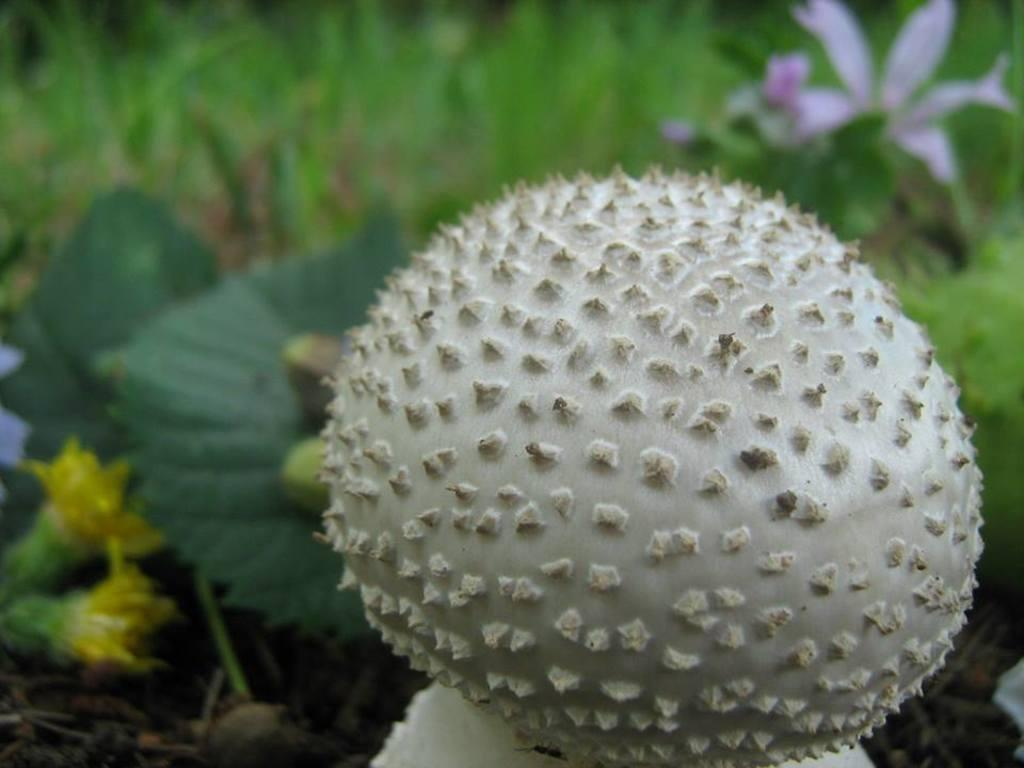What type of mushroom is visible in the image? There is a stick horn mushroom in the image. Where is the mushroom located? The mushroom is present on a plant. What other types of flora can be seen in the image? There are other flowers and plants in the image. How many pizzas are being served at the school in the image? There are no pizzas or schools present in the image; it features a stick horn mushroom on a plant and other flora. 